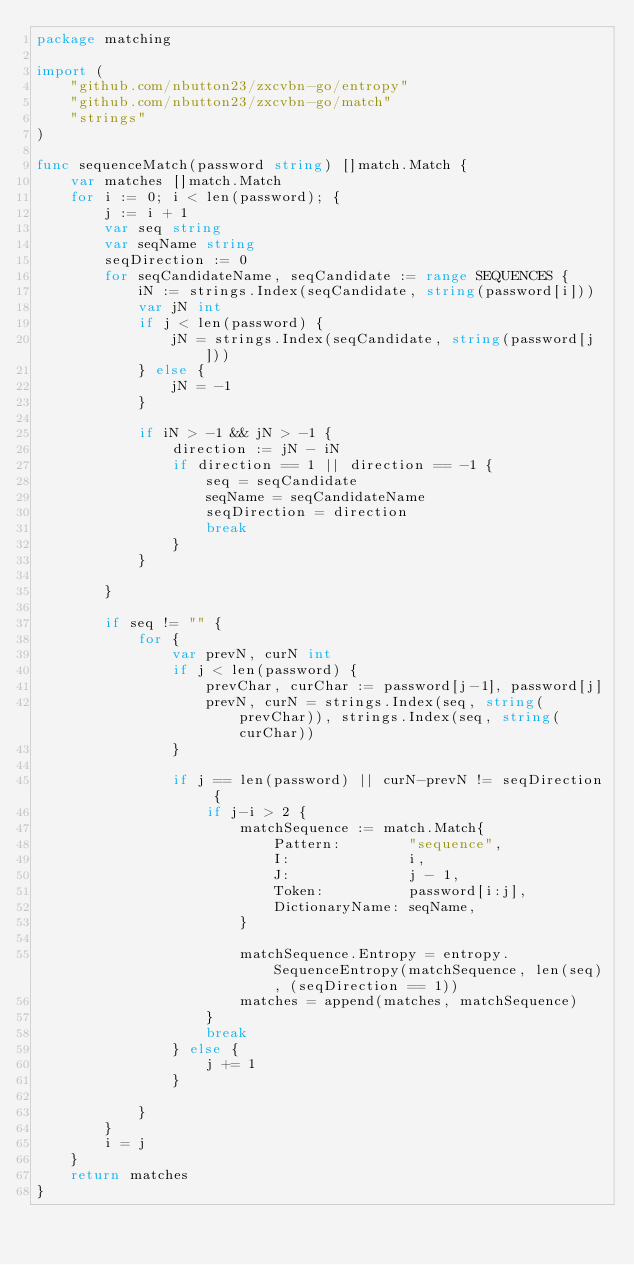<code> <loc_0><loc_0><loc_500><loc_500><_Go_>package matching

import (
	"github.com/nbutton23/zxcvbn-go/entropy"
	"github.com/nbutton23/zxcvbn-go/match"
	"strings"
)

func sequenceMatch(password string) []match.Match {
	var matches []match.Match
	for i := 0; i < len(password); {
		j := i + 1
		var seq string
		var seqName string
		seqDirection := 0
		for seqCandidateName, seqCandidate := range SEQUENCES {
			iN := strings.Index(seqCandidate, string(password[i]))
			var jN int
			if j < len(password) {
				jN = strings.Index(seqCandidate, string(password[j]))
			} else {
				jN = -1
			}

			if iN > -1 && jN > -1 {
				direction := jN - iN
				if direction == 1 || direction == -1 {
					seq = seqCandidate
					seqName = seqCandidateName
					seqDirection = direction
					break
				}
			}

		}

		if seq != "" {
			for {
				var prevN, curN int
				if j < len(password) {
					prevChar, curChar := password[j-1], password[j]
					prevN, curN = strings.Index(seq, string(prevChar)), strings.Index(seq, string(curChar))
				}

				if j == len(password) || curN-prevN != seqDirection {
					if j-i > 2 {
						matchSequence := match.Match{
							Pattern:        "sequence",
							I:              i,
							J:              j - 1,
							Token:          password[i:j],
							DictionaryName: seqName,
						}

						matchSequence.Entropy = entropy.SequenceEntropy(matchSequence, len(seq), (seqDirection == 1))
						matches = append(matches, matchSequence)
					}
					break
				} else {
					j += 1
				}

			}
		}
		i = j
	}
	return matches
}
</code> 